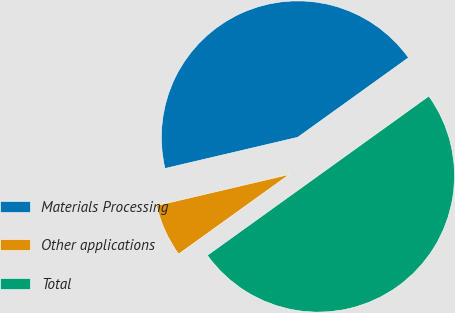<chart> <loc_0><loc_0><loc_500><loc_500><pie_chart><fcel>Materials Processing<fcel>Other applications<fcel>Total<nl><fcel>43.75%<fcel>6.25%<fcel>50.0%<nl></chart> 